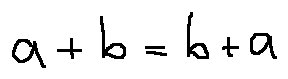<formula> <loc_0><loc_0><loc_500><loc_500>a + b = b + a</formula> 